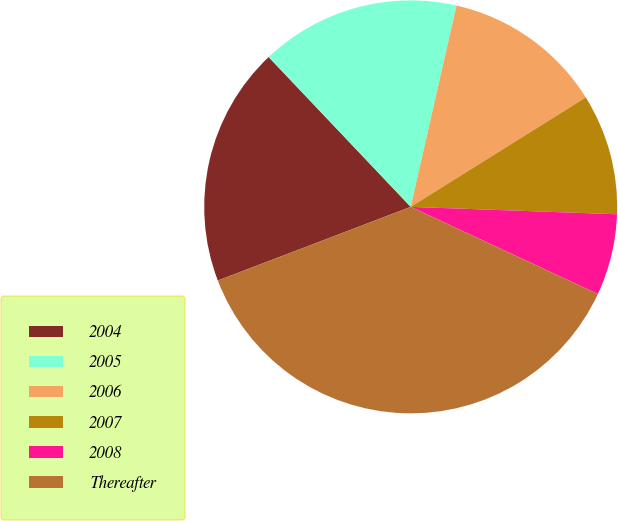<chart> <loc_0><loc_0><loc_500><loc_500><pie_chart><fcel>2004<fcel>2005<fcel>2006<fcel>2007<fcel>2008<fcel>Thereafter<nl><fcel>18.73%<fcel>15.64%<fcel>12.55%<fcel>9.46%<fcel>6.37%<fcel>37.26%<nl></chart> 